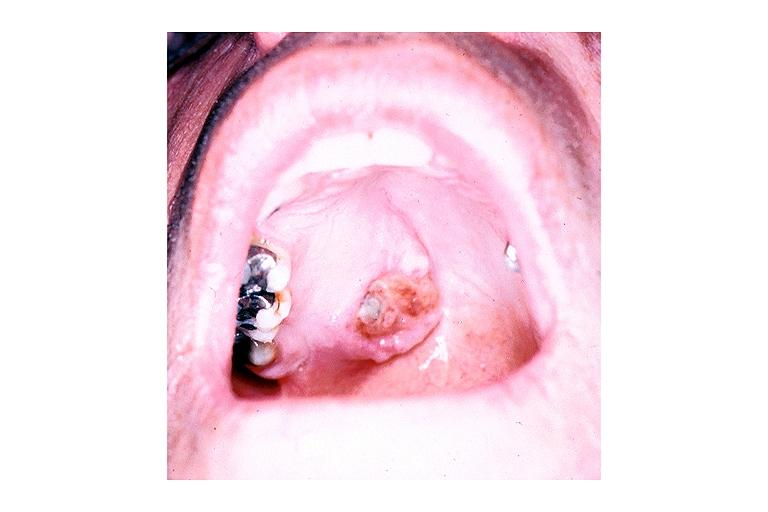s brain present?
Answer the question using a single word or phrase. No 